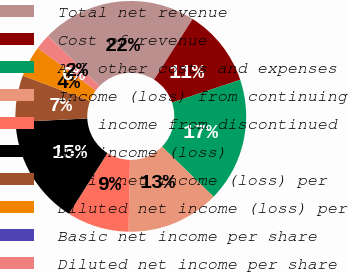Convert chart. <chart><loc_0><loc_0><loc_500><loc_500><pie_chart><fcel>Total net revenue<fcel>Cost of revenue<fcel>All other costs and expenses<fcel>Income (loss) from continuing<fcel>Net income from discontinued<fcel>Net income (loss)<fcel>Basic net income (loss) per<fcel>Diluted net income (loss) per<fcel>Basic net income per share<fcel>Diluted net income per share<nl><fcel>21.74%<fcel>10.87%<fcel>17.39%<fcel>13.04%<fcel>8.7%<fcel>15.22%<fcel>6.52%<fcel>4.35%<fcel>0.0%<fcel>2.17%<nl></chart> 